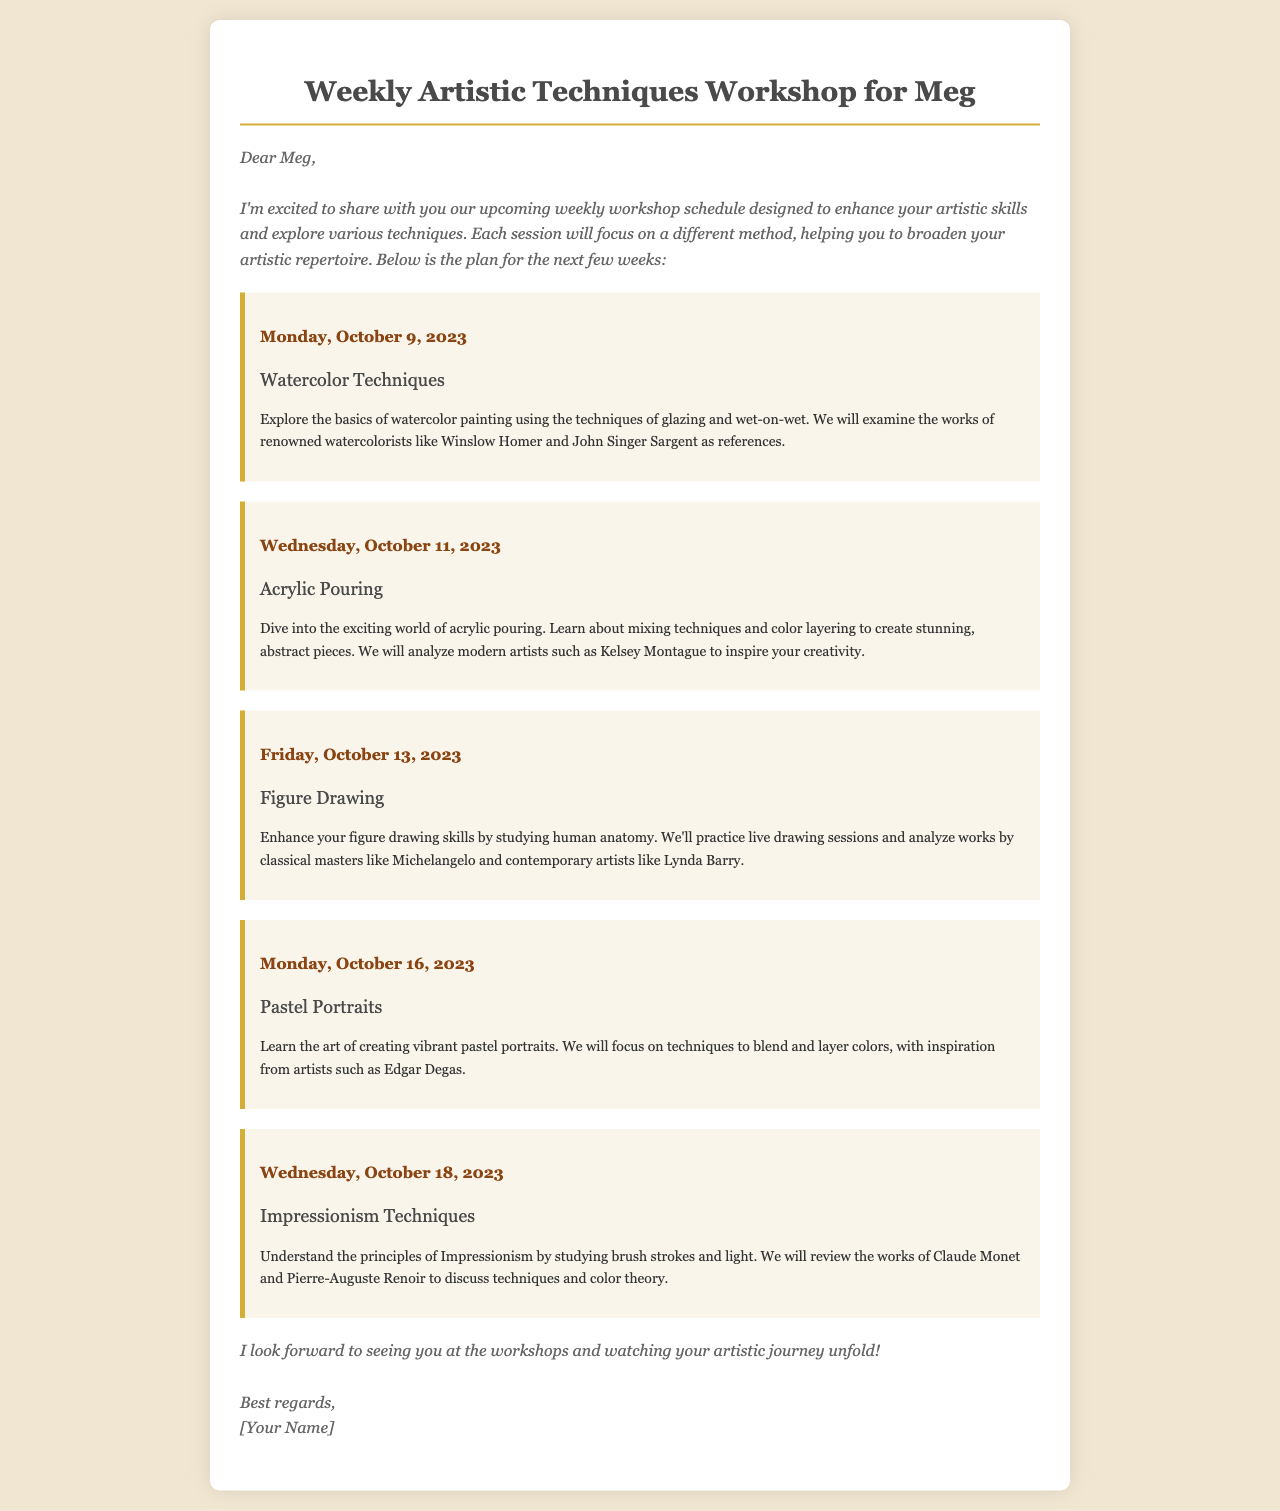What is the first workshop topic? The first workshop topic is listed on Monday, October 9, 2023, as Watercolor Techniques.
Answer: Watercolor Techniques When is the Figure Drawing workshop scheduled? The Figure Drawing workshop is scheduled for Friday, October 13, 2023.
Answer: Friday, October 13, 2023 Which artist is referenced in the Pastel Portraits session? The Pastel Portraits session references Edgar Degas for inspiration.
Answer: Edgar Degas How many workshops are there in total? There are five workshops outlined in the document: Watercolor Techniques, Acrylic Pouring, Figure Drawing, Pastel Portraits, and Impressionism Techniques.
Answer: Five What artistic movement will be studied in the Impressionism Techniques session? The Impressionism Techniques session will focus on the principles of Impressionism.
Answer: Impressionism Which date features a workshop on Acrylic Pouring? The workshop on Acrylic Pouring is scheduled for Wednesday, October 11, 2023.
Answer: Wednesday, October 11, 2023 What is the main focus of the figure drawing session? The focus of the Figure Drawing session is to study human anatomy.
Answer: Human anatomy Who is the intended recipient of the workshop schedule? The workshop schedule is addressed to Meg.
Answer: Meg 